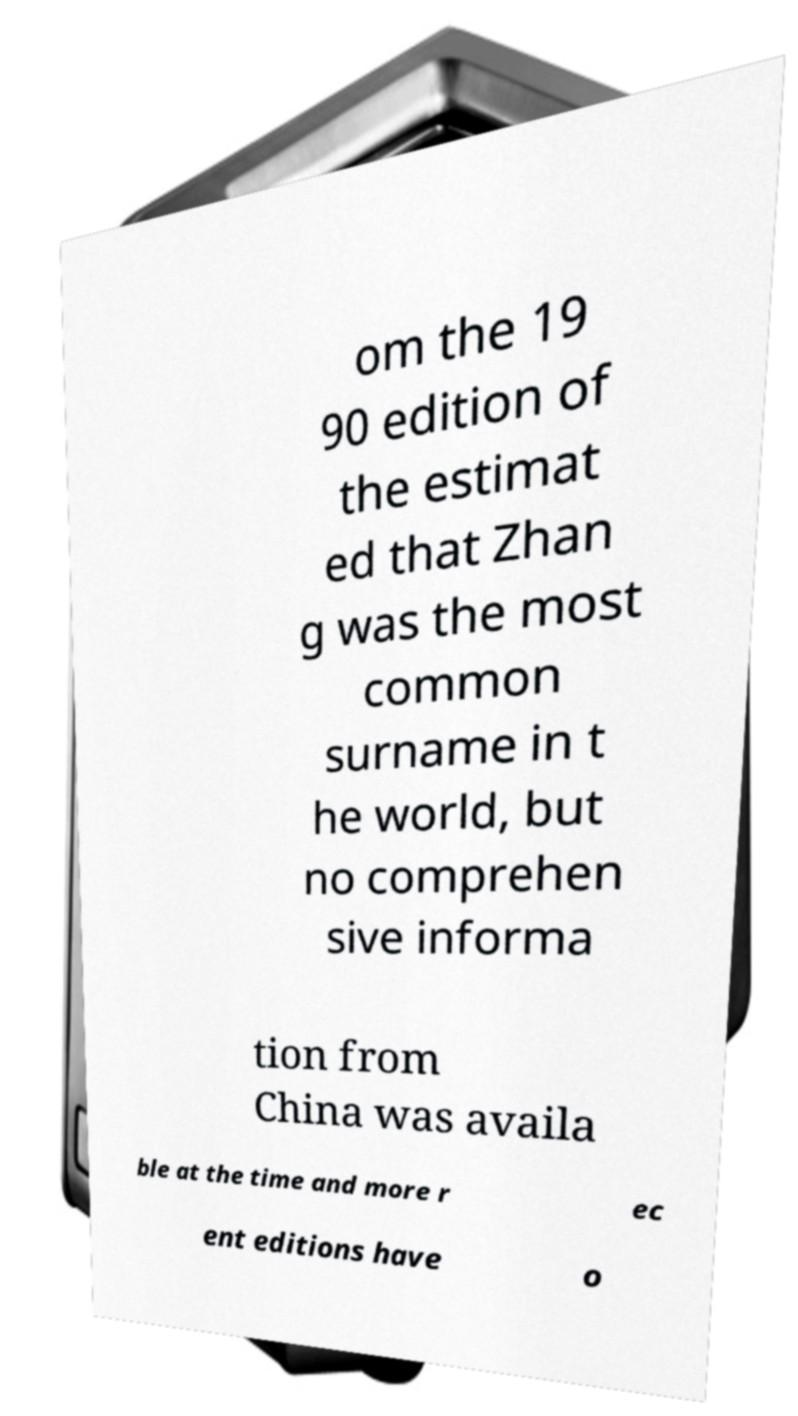For documentation purposes, I need the text within this image transcribed. Could you provide that? om the 19 90 edition of the estimat ed that Zhan g was the most common surname in t he world, but no comprehen sive informa tion from China was availa ble at the time and more r ec ent editions have o 